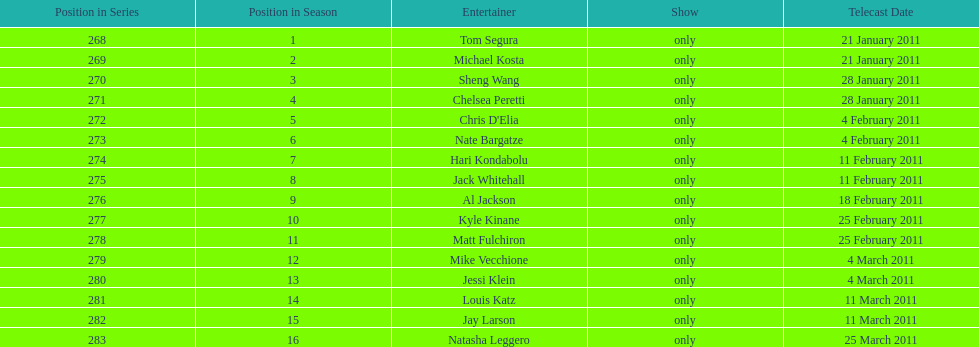What is the name of the last performer on this chart? Natasha Leggero. 